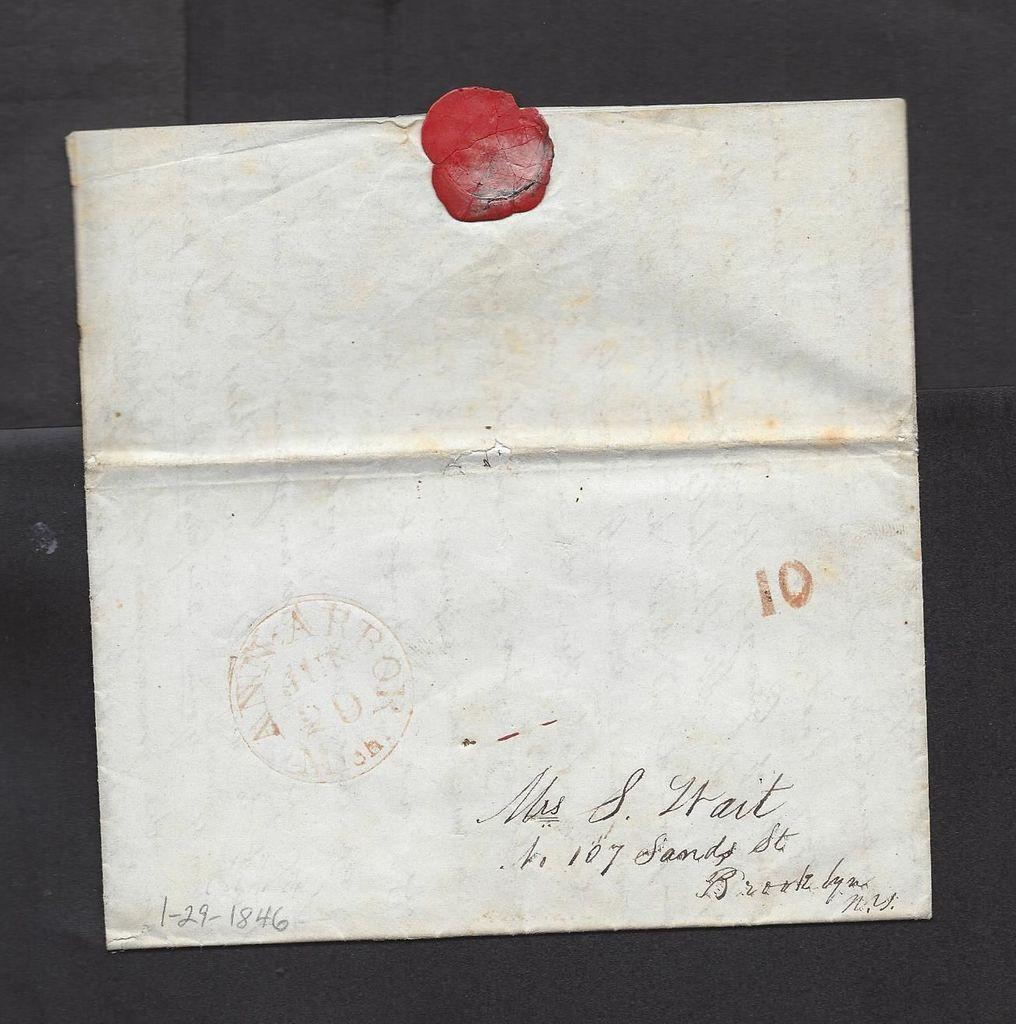<image>
Give a short and clear explanation of the subsequent image. Signed letter that was written to someone back in 1846 